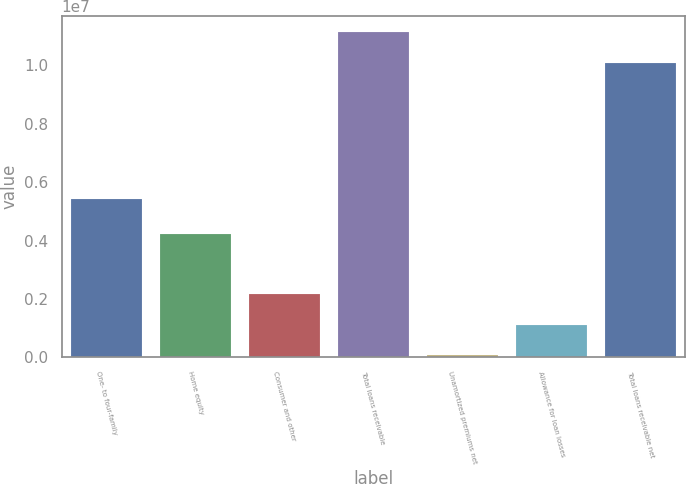<chart> <loc_0><loc_0><loc_500><loc_500><bar_chart><fcel>One- to four-family<fcel>Home equity<fcel>Consumer and other<fcel>Total loans receivable<fcel>Unamortized premiums net<fcel>Allowance for loan losses<fcel>Total loans receivable net<nl><fcel>5.44217e+06<fcel>4.22346e+06<fcel>2.15723e+06<fcel>1.11429e+07<fcel>68897<fcel>1.11306e+06<fcel>1.00987e+07<nl></chart> 